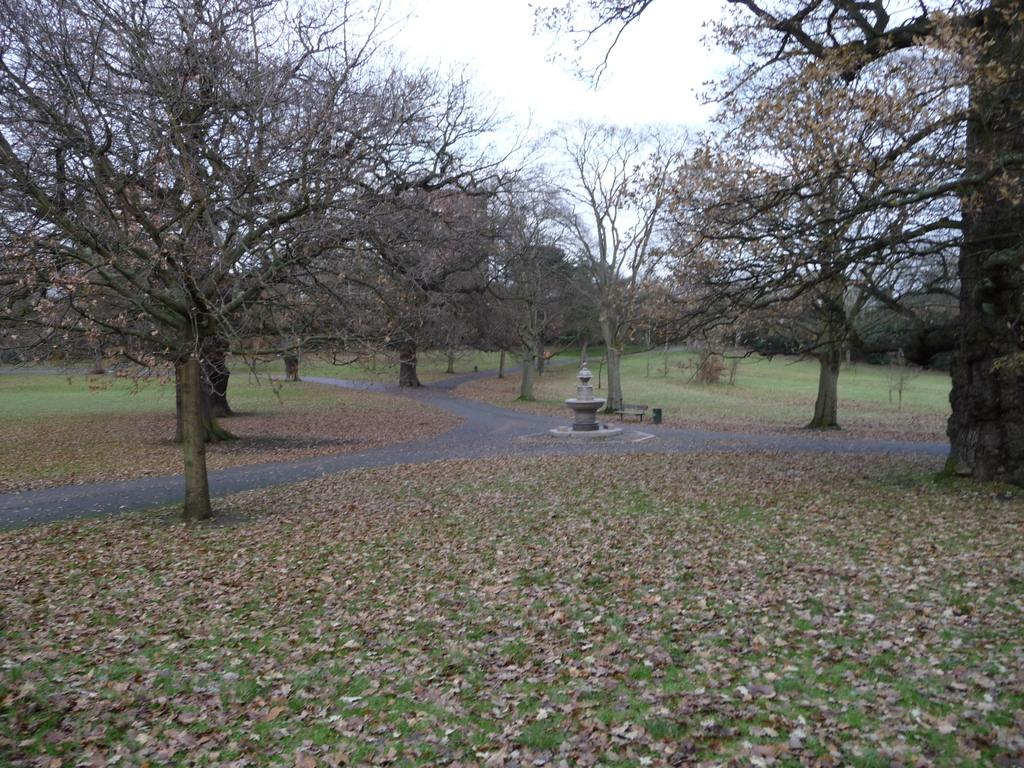What type of vegetation can be seen in the image? There are trees and grass in the image. What type of ground surface is visible in the image? There are roads and leaves on the ground in the image. What else can be seen in the image besides vegetation and ground surfaces? There are other objects in the image. What is visible in the background of the image? The sky is visible in the background of the image. What holiday is being celebrated in the image? There is no indication of a holiday being celebrated in the image. What is the aftermath of the event depicted in the image? There is no event depicted in the image, so it is not possible to determine the aftermath. 